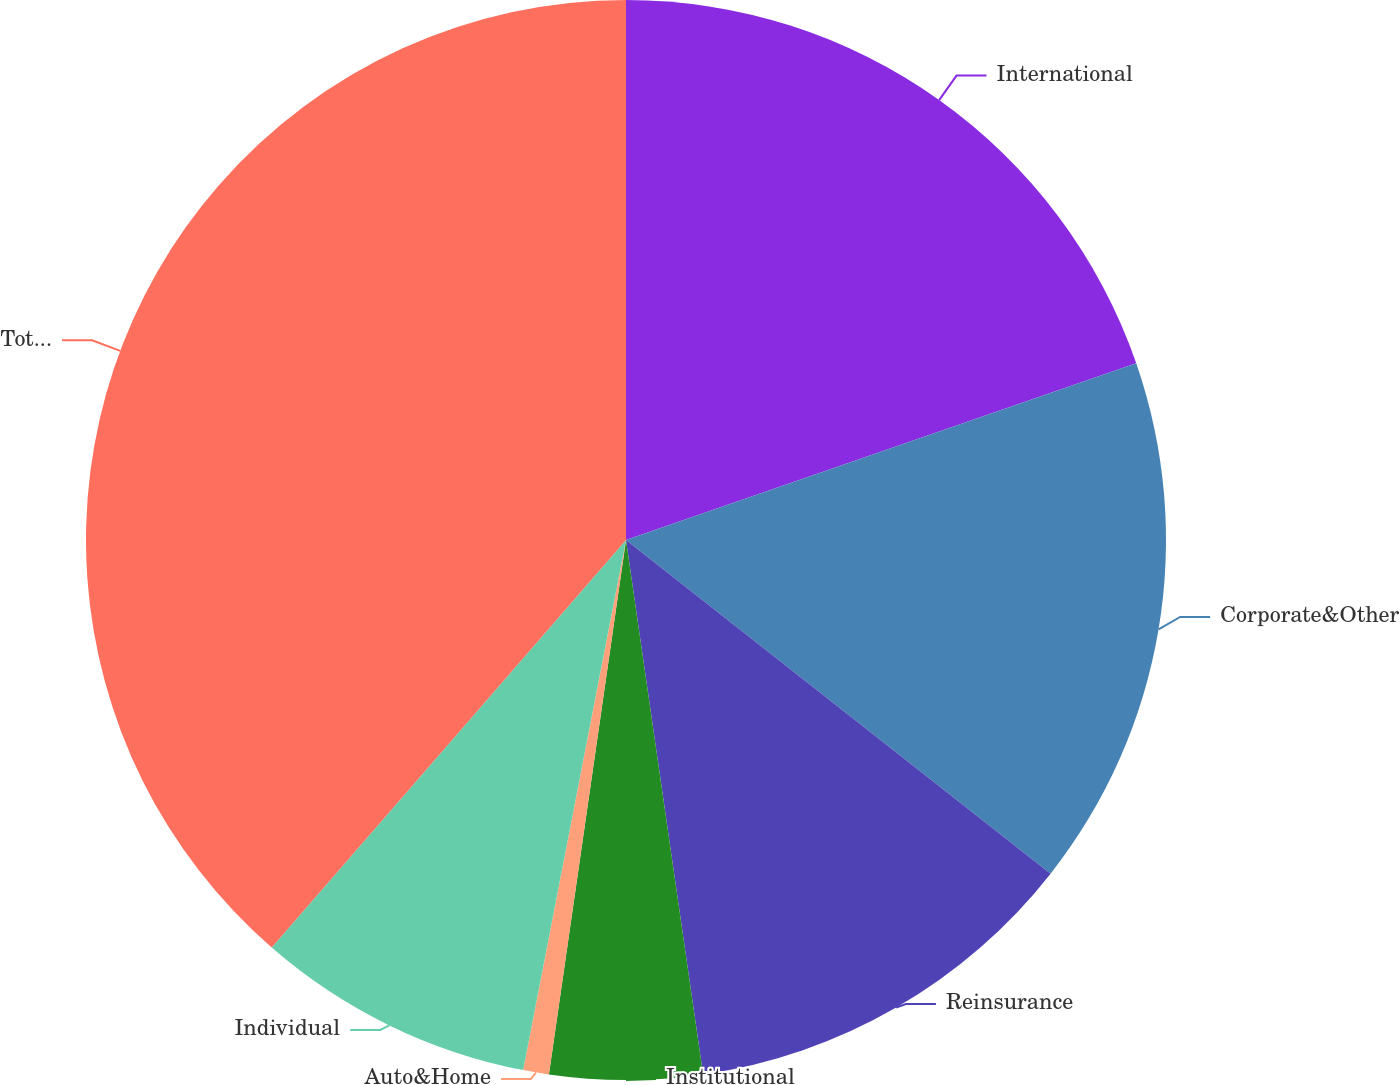Convert chart. <chart><loc_0><loc_0><loc_500><loc_500><pie_chart><fcel>International<fcel>Corporate&Other<fcel>Reinsurance<fcel>Institutional<fcel>Auto&Home<fcel>Individual<fcel>Totalchange<nl><fcel>19.69%<fcel>15.91%<fcel>12.12%<fcel>4.56%<fcel>0.77%<fcel>8.34%<fcel>38.61%<nl></chart> 